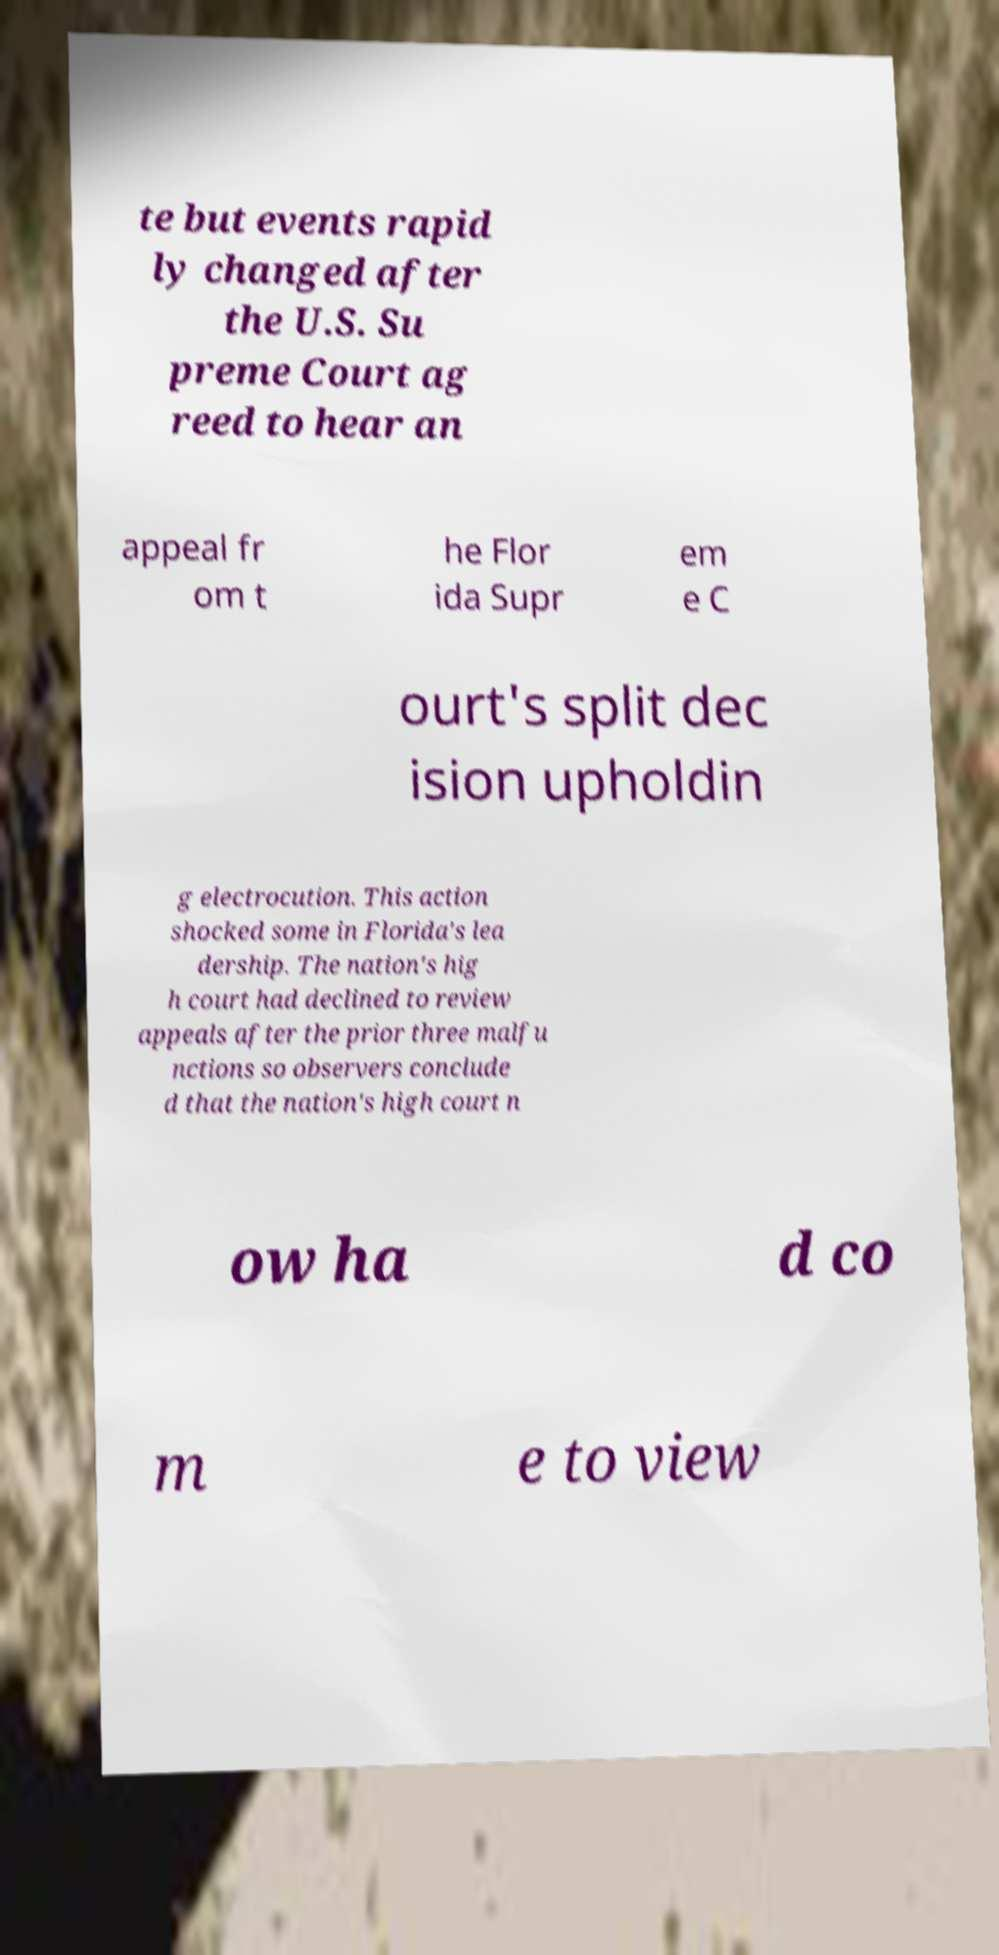Please identify and transcribe the text found in this image. te but events rapid ly changed after the U.S. Su preme Court ag reed to hear an appeal fr om t he Flor ida Supr em e C ourt's split dec ision upholdin g electrocution. This action shocked some in Florida's lea dership. The nation's hig h court had declined to review appeals after the prior three malfu nctions so observers conclude d that the nation's high court n ow ha d co m e to view 